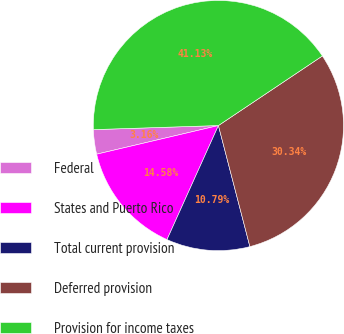<chart> <loc_0><loc_0><loc_500><loc_500><pie_chart><fcel>Federal<fcel>States and Puerto Rico<fcel>Total current provision<fcel>Deferred provision<fcel>Provision for income taxes<nl><fcel>3.16%<fcel>14.58%<fcel>10.79%<fcel>30.34%<fcel>41.13%<nl></chart> 